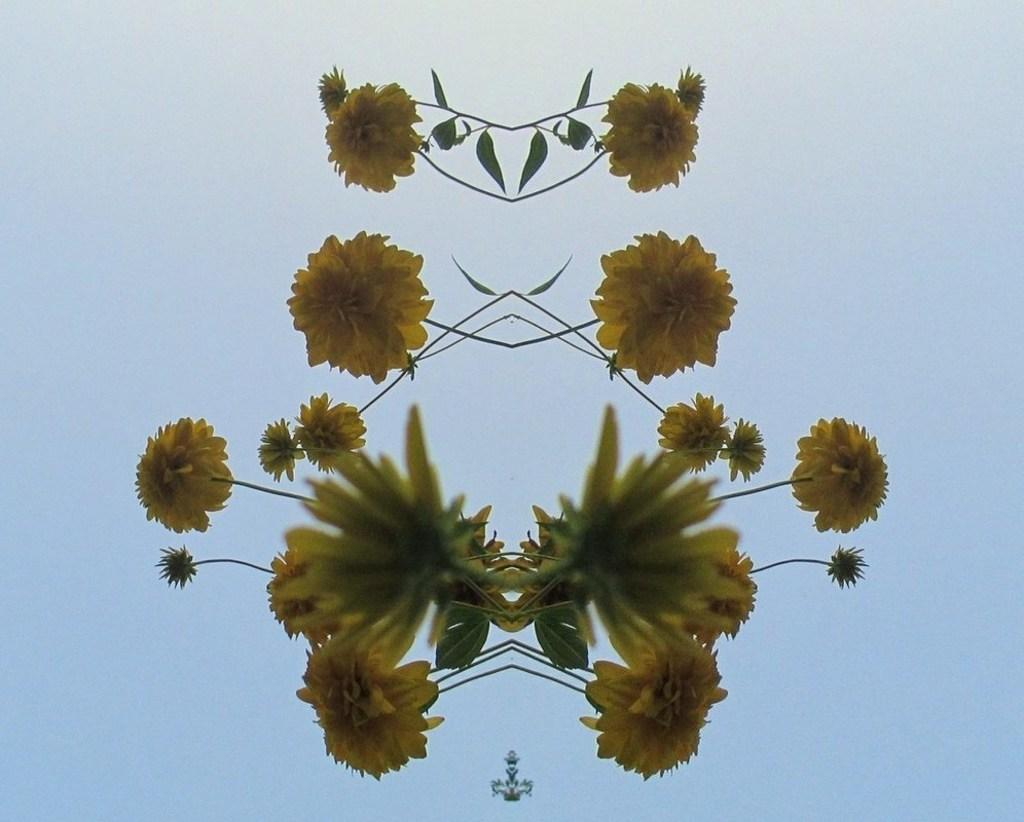What type of plants can be seen in the image? There are flowers and leaves in the image. What color is the background of the image? The background of the image is blue in color. How many rings are visible on the flowers in the image? There are no rings visible on the flowers in the image. What type of sugar is being used to water the plants in the image? There is no sugar present in the image, and the plants are not being watered. 